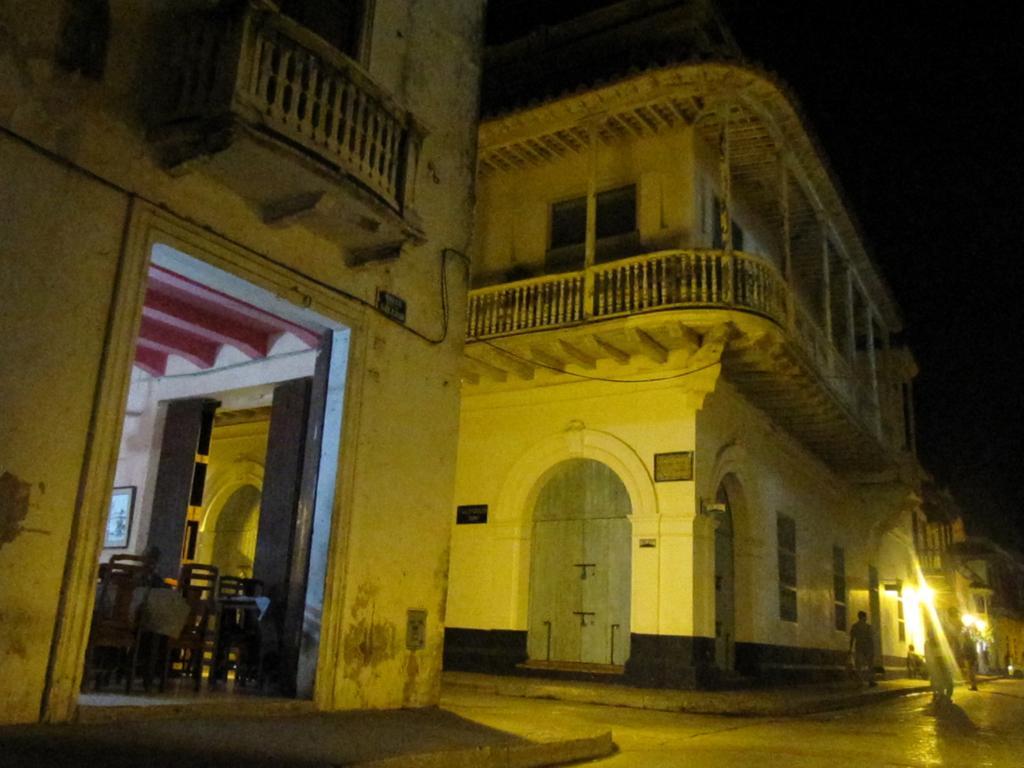Can you describe this image briefly? In this image there are people walking on the pavement. There are lights. On the left side of the image there are chairs. There is a photo frame on the wall. In the background of the image there are buildings and sky. 